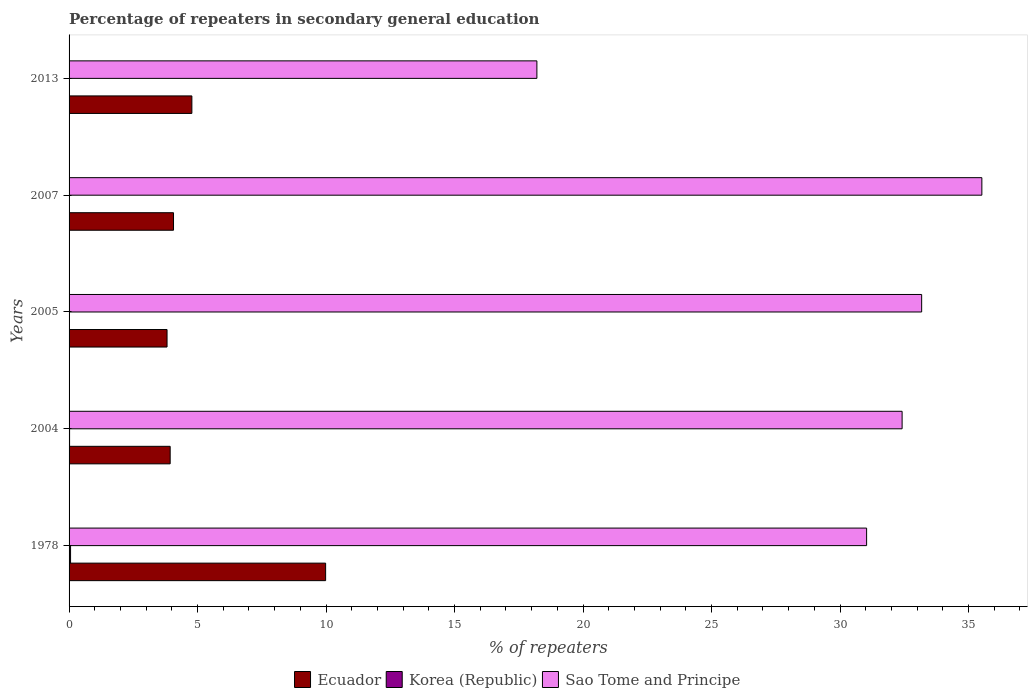Are the number of bars on each tick of the Y-axis equal?
Your answer should be very brief. Yes. How many bars are there on the 2nd tick from the top?
Offer a terse response. 3. How many bars are there on the 3rd tick from the bottom?
Make the answer very short. 3. What is the label of the 5th group of bars from the top?
Your answer should be very brief. 1978. In how many cases, is the number of bars for a given year not equal to the number of legend labels?
Provide a succinct answer. 0. What is the percentage of repeaters in secondary general education in Ecuador in 2013?
Your answer should be very brief. 4.78. Across all years, what is the maximum percentage of repeaters in secondary general education in Sao Tome and Principe?
Offer a terse response. 35.52. Across all years, what is the minimum percentage of repeaters in secondary general education in Sao Tome and Principe?
Ensure brevity in your answer.  18.2. In which year was the percentage of repeaters in secondary general education in Ecuador maximum?
Keep it short and to the point. 1978. In which year was the percentage of repeaters in secondary general education in Sao Tome and Principe minimum?
Offer a very short reply. 2013. What is the total percentage of repeaters in secondary general education in Sao Tome and Principe in the graph?
Provide a short and direct response. 150.34. What is the difference between the percentage of repeaters in secondary general education in Korea (Republic) in 2004 and that in 2013?
Make the answer very short. 0.01. What is the difference between the percentage of repeaters in secondary general education in Ecuador in 1978 and the percentage of repeaters in secondary general education in Korea (Republic) in 2007?
Make the answer very short. 9.98. What is the average percentage of repeaters in secondary general education in Korea (Republic) per year?
Provide a succinct answer. 0.02. In the year 2013, what is the difference between the percentage of repeaters in secondary general education in Korea (Republic) and percentage of repeaters in secondary general education in Sao Tome and Principe?
Provide a short and direct response. -18.2. In how many years, is the percentage of repeaters in secondary general education in Ecuador greater than 15 %?
Offer a terse response. 0. What is the ratio of the percentage of repeaters in secondary general education in Korea (Republic) in 1978 to that in 2013?
Provide a short and direct response. 10.37. Is the percentage of repeaters in secondary general education in Sao Tome and Principe in 1978 less than that in 2007?
Make the answer very short. Yes. What is the difference between the highest and the second highest percentage of repeaters in secondary general education in Ecuador?
Provide a short and direct response. 5.2. What is the difference between the highest and the lowest percentage of repeaters in secondary general education in Ecuador?
Your response must be concise. 6.17. In how many years, is the percentage of repeaters in secondary general education in Sao Tome and Principe greater than the average percentage of repeaters in secondary general education in Sao Tome and Principe taken over all years?
Provide a short and direct response. 4. Is the sum of the percentage of repeaters in secondary general education in Sao Tome and Principe in 2007 and 2013 greater than the maximum percentage of repeaters in secondary general education in Korea (Republic) across all years?
Ensure brevity in your answer.  Yes. What does the 1st bar from the top in 2007 represents?
Make the answer very short. Sao Tome and Principe. Is it the case that in every year, the sum of the percentage of repeaters in secondary general education in Korea (Republic) and percentage of repeaters in secondary general education in Sao Tome and Principe is greater than the percentage of repeaters in secondary general education in Ecuador?
Make the answer very short. Yes. How many years are there in the graph?
Your response must be concise. 5. Are the values on the major ticks of X-axis written in scientific E-notation?
Ensure brevity in your answer.  No. Does the graph contain grids?
Ensure brevity in your answer.  No. Where does the legend appear in the graph?
Provide a short and direct response. Bottom center. How many legend labels are there?
Your answer should be very brief. 3. What is the title of the graph?
Offer a terse response. Percentage of repeaters in secondary general education. What is the label or title of the X-axis?
Provide a succinct answer. % of repeaters. What is the % of repeaters of Ecuador in 1978?
Provide a short and direct response. 9.98. What is the % of repeaters in Korea (Republic) in 1978?
Provide a succinct answer. 0.06. What is the % of repeaters in Sao Tome and Principe in 1978?
Give a very brief answer. 31.03. What is the % of repeaters in Ecuador in 2004?
Ensure brevity in your answer.  3.93. What is the % of repeaters of Korea (Republic) in 2004?
Your answer should be very brief. 0.02. What is the % of repeaters of Sao Tome and Principe in 2004?
Keep it short and to the point. 32.41. What is the % of repeaters in Ecuador in 2005?
Provide a short and direct response. 3.81. What is the % of repeaters of Korea (Republic) in 2005?
Offer a terse response. 0. What is the % of repeaters in Sao Tome and Principe in 2005?
Make the answer very short. 33.18. What is the % of repeaters of Ecuador in 2007?
Provide a succinct answer. 4.06. What is the % of repeaters in Korea (Republic) in 2007?
Keep it short and to the point. 0. What is the % of repeaters of Sao Tome and Principe in 2007?
Keep it short and to the point. 35.52. What is the % of repeaters of Ecuador in 2013?
Provide a short and direct response. 4.78. What is the % of repeaters in Korea (Republic) in 2013?
Offer a very short reply. 0.01. What is the % of repeaters in Sao Tome and Principe in 2013?
Your answer should be very brief. 18.2. Across all years, what is the maximum % of repeaters of Ecuador?
Offer a terse response. 9.98. Across all years, what is the maximum % of repeaters of Korea (Republic)?
Provide a short and direct response. 0.06. Across all years, what is the maximum % of repeaters in Sao Tome and Principe?
Provide a short and direct response. 35.52. Across all years, what is the minimum % of repeaters in Ecuador?
Offer a terse response. 3.81. Across all years, what is the minimum % of repeaters in Korea (Republic)?
Keep it short and to the point. 0. Across all years, what is the minimum % of repeaters of Sao Tome and Principe?
Your answer should be compact. 18.2. What is the total % of repeaters in Ecuador in the graph?
Provide a succinct answer. 26.57. What is the total % of repeaters of Korea (Republic) in the graph?
Offer a very short reply. 0.09. What is the total % of repeaters in Sao Tome and Principe in the graph?
Your response must be concise. 150.34. What is the difference between the % of repeaters in Ecuador in 1978 and that in 2004?
Your answer should be very brief. 6.05. What is the difference between the % of repeaters of Korea (Republic) in 1978 and that in 2004?
Offer a very short reply. 0.04. What is the difference between the % of repeaters in Sao Tome and Principe in 1978 and that in 2004?
Ensure brevity in your answer.  -1.38. What is the difference between the % of repeaters of Ecuador in 1978 and that in 2005?
Your answer should be compact. 6.17. What is the difference between the % of repeaters in Korea (Republic) in 1978 and that in 2005?
Offer a terse response. 0.05. What is the difference between the % of repeaters in Sao Tome and Principe in 1978 and that in 2005?
Make the answer very short. -2.14. What is the difference between the % of repeaters of Ecuador in 1978 and that in 2007?
Your answer should be very brief. 5.92. What is the difference between the % of repeaters in Korea (Republic) in 1978 and that in 2007?
Provide a short and direct response. 0.05. What is the difference between the % of repeaters in Sao Tome and Principe in 1978 and that in 2007?
Offer a terse response. -4.48. What is the difference between the % of repeaters in Ecuador in 1978 and that in 2013?
Ensure brevity in your answer.  5.2. What is the difference between the % of repeaters of Korea (Republic) in 1978 and that in 2013?
Your response must be concise. 0.05. What is the difference between the % of repeaters in Sao Tome and Principe in 1978 and that in 2013?
Give a very brief answer. 12.83. What is the difference between the % of repeaters of Ecuador in 2004 and that in 2005?
Your answer should be compact. 0.12. What is the difference between the % of repeaters of Korea (Republic) in 2004 and that in 2005?
Provide a succinct answer. 0.02. What is the difference between the % of repeaters in Sao Tome and Principe in 2004 and that in 2005?
Offer a very short reply. -0.76. What is the difference between the % of repeaters in Ecuador in 2004 and that in 2007?
Provide a succinct answer. -0.13. What is the difference between the % of repeaters in Korea (Republic) in 2004 and that in 2007?
Your answer should be compact. 0.02. What is the difference between the % of repeaters of Sao Tome and Principe in 2004 and that in 2007?
Your answer should be compact. -3.1. What is the difference between the % of repeaters of Ecuador in 2004 and that in 2013?
Your response must be concise. -0.84. What is the difference between the % of repeaters of Korea (Republic) in 2004 and that in 2013?
Keep it short and to the point. 0.01. What is the difference between the % of repeaters in Sao Tome and Principe in 2004 and that in 2013?
Offer a very short reply. 14.21. What is the difference between the % of repeaters in Ecuador in 2005 and that in 2007?
Your answer should be compact. -0.25. What is the difference between the % of repeaters in Korea (Republic) in 2005 and that in 2007?
Your answer should be compact. 0. What is the difference between the % of repeaters in Sao Tome and Principe in 2005 and that in 2007?
Offer a terse response. -2.34. What is the difference between the % of repeaters of Ecuador in 2005 and that in 2013?
Your answer should be very brief. -0.97. What is the difference between the % of repeaters in Korea (Republic) in 2005 and that in 2013?
Offer a very short reply. -0. What is the difference between the % of repeaters of Sao Tome and Principe in 2005 and that in 2013?
Your answer should be compact. 14.97. What is the difference between the % of repeaters of Ecuador in 2007 and that in 2013?
Ensure brevity in your answer.  -0.71. What is the difference between the % of repeaters of Korea (Republic) in 2007 and that in 2013?
Keep it short and to the point. -0. What is the difference between the % of repeaters of Sao Tome and Principe in 2007 and that in 2013?
Offer a terse response. 17.31. What is the difference between the % of repeaters of Ecuador in 1978 and the % of repeaters of Korea (Republic) in 2004?
Your answer should be compact. 9.96. What is the difference between the % of repeaters of Ecuador in 1978 and the % of repeaters of Sao Tome and Principe in 2004?
Offer a very short reply. -22.43. What is the difference between the % of repeaters in Korea (Republic) in 1978 and the % of repeaters in Sao Tome and Principe in 2004?
Provide a succinct answer. -32.36. What is the difference between the % of repeaters in Ecuador in 1978 and the % of repeaters in Korea (Republic) in 2005?
Your response must be concise. 9.98. What is the difference between the % of repeaters of Ecuador in 1978 and the % of repeaters of Sao Tome and Principe in 2005?
Your answer should be compact. -23.19. What is the difference between the % of repeaters in Korea (Republic) in 1978 and the % of repeaters in Sao Tome and Principe in 2005?
Offer a very short reply. -33.12. What is the difference between the % of repeaters of Ecuador in 1978 and the % of repeaters of Korea (Republic) in 2007?
Your answer should be compact. 9.98. What is the difference between the % of repeaters in Ecuador in 1978 and the % of repeaters in Sao Tome and Principe in 2007?
Provide a short and direct response. -25.53. What is the difference between the % of repeaters in Korea (Republic) in 1978 and the % of repeaters in Sao Tome and Principe in 2007?
Ensure brevity in your answer.  -35.46. What is the difference between the % of repeaters of Ecuador in 1978 and the % of repeaters of Korea (Republic) in 2013?
Make the answer very short. 9.98. What is the difference between the % of repeaters of Ecuador in 1978 and the % of repeaters of Sao Tome and Principe in 2013?
Your response must be concise. -8.22. What is the difference between the % of repeaters in Korea (Republic) in 1978 and the % of repeaters in Sao Tome and Principe in 2013?
Provide a succinct answer. -18.15. What is the difference between the % of repeaters in Ecuador in 2004 and the % of repeaters in Korea (Republic) in 2005?
Your answer should be compact. 3.93. What is the difference between the % of repeaters of Ecuador in 2004 and the % of repeaters of Sao Tome and Principe in 2005?
Provide a short and direct response. -29.24. What is the difference between the % of repeaters in Korea (Republic) in 2004 and the % of repeaters in Sao Tome and Principe in 2005?
Your response must be concise. -33.16. What is the difference between the % of repeaters of Ecuador in 2004 and the % of repeaters of Korea (Republic) in 2007?
Ensure brevity in your answer.  3.93. What is the difference between the % of repeaters in Ecuador in 2004 and the % of repeaters in Sao Tome and Principe in 2007?
Your response must be concise. -31.58. What is the difference between the % of repeaters in Korea (Republic) in 2004 and the % of repeaters in Sao Tome and Principe in 2007?
Provide a short and direct response. -35.5. What is the difference between the % of repeaters in Ecuador in 2004 and the % of repeaters in Korea (Republic) in 2013?
Keep it short and to the point. 3.93. What is the difference between the % of repeaters of Ecuador in 2004 and the % of repeaters of Sao Tome and Principe in 2013?
Provide a short and direct response. -14.27. What is the difference between the % of repeaters of Korea (Republic) in 2004 and the % of repeaters of Sao Tome and Principe in 2013?
Offer a very short reply. -18.18. What is the difference between the % of repeaters in Ecuador in 2005 and the % of repeaters in Korea (Republic) in 2007?
Provide a succinct answer. 3.81. What is the difference between the % of repeaters of Ecuador in 2005 and the % of repeaters of Sao Tome and Principe in 2007?
Give a very brief answer. -31.71. What is the difference between the % of repeaters of Korea (Republic) in 2005 and the % of repeaters of Sao Tome and Principe in 2007?
Provide a short and direct response. -35.51. What is the difference between the % of repeaters in Ecuador in 2005 and the % of repeaters in Korea (Republic) in 2013?
Keep it short and to the point. 3.81. What is the difference between the % of repeaters of Ecuador in 2005 and the % of repeaters of Sao Tome and Principe in 2013?
Provide a succinct answer. -14.39. What is the difference between the % of repeaters of Korea (Republic) in 2005 and the % of repeaters of Sao Tome and Principe in 2013?
Keep it short and to the point. -18.2. What is the difference between the % of repeaters of Ecuador in 2007 and the % of repeaters of Korea (Republic) in 2013?
Your answer should be compact. 4.06. What is the difference between the % of repeaters in Ecuador in 2007 and the % of repeaters in Sao Tome and Principe in 2013?
Keep it short and to the point. -14.14. What is the difference between the % of repeaters in Korea (Republic) in 2007 and the % of repeaters in Sao Tome and Principe in 2013?
Make the answer very short. -18.2. What is the average % of repeaters of Ecuador per year?
Your answer should be very brief. 5.31. What is the average % of repeaters in Korea (Republic) per year?
Ensure brevity in your answer.  0.02. What is the average % of repeaters in Sao Tome and Principe per year?
Give a very brief answer. 30.07. In the year 1978, what is the difference between the % of repeaters in Ecuador and % of repeaters in Korea (Republic)?
Make the answer very short. 9.92. In the year 1978, what is the difference between the % of repeaters in Ecuador and % of repeaters in Sao Tome and Principe?
Your response must be concise. -21.05. In the year 1978, what is the difference between the % of repeaters in Korea (Republic) and % of repeaters in Sao Tome and Principe?
Make the answer very short. -30.98. In the year 2004, what is the difference between the % of repeaters of Ecuador and % of repeaters of Korea (Republic)?
Offer a very short reply. 3.91. In the year 2004, what is the difference between the % of repeaters of Ecuador and % of repeaters of Sao Tome and Principe?
Provide a succinct answer. -28.48. In the year 2004, what is the difference between the % of repeaters in Korea (Republic) and % of repeaters in Sao Tome and Principe?
Your response must be concise. -32.4. In the year 2005, what is the difference between the % of repeaters in Ecuador and % of repeaters in Korea (Republic)?
Offer a very short reply. 3.81. In the year 2005, what is the difference between the % of repeaters of Ecuador and % of repeaters of Sao Tome and Principe?
Offer a terse response. -29.36. In the year 2005, what is the difference between the % of repeaters of Korea (Republic) and % of repeaters of Sao Tome and Principe?
Your response must be concise. -33.17. In the year 2007, what is the difference between the % of repeaters in Ecuador and % of repeaters in Korea (Republic)?
Provide a short and direct response. 4.06. In the year 2007, what is the difference between the % of repeaters in Ecuador and % of repeaters in Sao Tome and Principe?
Offer a terse response. -31.45. In the year 2007, what is the difference between the % of repeaters of Korea (Republic) and % of repeaters of Sao Tome and Principe?
Your response must be concise. -35.51. In the year 2013, what is the difference between the % of repeaters in Ecuador and % of repeaters in Korea (Republic)?
Make the answer very short. 4.77. In the year 2013, what is the difference between the % of repeaters in Ecuador and % of repeaters in Sao Tome and Principe?
Offer a very short reply. -13.43. In the year 2013, what is the difference between the % of repeaters in Korea (Republic) and % of repeaters in Sao Tome and Principe?
Make the answer very short. -18.2. What is the ratio of the % of repeaters in Ecuador in 1978 to that in 2004?
Make the answer very short. 2.54. What is the ratio of the % of repeaters in Korea (Republic) in 1978 to that in 2004?
Offer a very short reply. 2.94. What is the ratio of the % of repeaters of Sao Tome and Principe in 1978 to that in 2004?
Provide a short and direct response. 0.96. What is the ratio of the % of repeaters in Ecuador in 1978 to that in 2005?
Offer a terse response. 2.62. What is the ratio of the % of repeaters of Korea (Republic) in 1978 to that in 2005?
Offer a very short reply. 12.92. What is the ratio of the % of repeaters of Sao Tome and Principe in 1978 to that in 2005?
Provide a succinct answer. 0.94. What is the ratio of the % of repeaters of Ecuador in 1978 to that in 2007?
Your answer should be compact. 2.46. What is the ratio of the % of repeaters of Korea (Republic) in 1978 to that in 2007?
Give a very brief answer. 13.49. What is the ratio of the % of repeaters of Sao Tome and Principe in 1978 to that in 2007?
Your response must be concise. 0.87. What is the ratio of the % of repeaters in Ecuador in 1978 to that in 2013?
Offer a terse response. 2.09. What is the ratio of the % of repeaters in Korea (Republic) in 1978 to that in 2013?
Offer a very short reply. 10.37. What is the ratio of the % of repeaters of Sao Tome and Principe in 1978 to that in 2013?
Provide a succinct answer. 1.7. What is the ratio of the % of repeaters in Ecuador in 2004 to that in 2005?
Give a very brief answer. 1.03. What is the ratio of the % of repeaters in Korea (Republic) in 2004 to that in 2005?
Your response must be concise. 4.39. What is the ratio of the % of repeaters in Sao Tome and Principe in 2004 to that in 2005?
Ensure brevity in your answer.  0.98. What is the ratio of the % of repeaters in Korea (Republic) in 2004 to that in 2007?
Make the answer very short. 4.59. What is the ratio of the % of repeaters of Sao Tome and Principe in 2004 to that in 2007?
Make the answer very short. 0.91. What is the ratio of the % of repeaters in Ecuador in 2004 to that in 2013?
Offer a terse response. 0.82. What is the ratio of the % of repeaters of Korea (Republic) in 2004 to that in 2013?
Make the answer very short. 3.53. What is the ratio of the % of repeaters in Sao Tome and Principe in 2004 to that in 2013?
Your answer should be very brief. 1.78. What is the ratio of the % of repeaters of Ecuador in 2005 to that in 2007?
Make the answer very short. 0.94. What is the ratio of the % of repeaters in Korea (Republic) in 2005 to that in 2007?
Give a very brief answer. 1.04. What is the ratio of the % of repeaters in Sao Tome and Principe in 2005 to that in 2007?
Provide a succinct answer. 0.93. What is the ratio of the % of repeaters of Ecuador in 2005 to that in 2013?
Provide a succinct answer. 0.8. What is the ratio of the % of repeaters in Korea (Republic) in 2005 to that in 2013?
Give a very brief answer. 0.8. What is the ratio of the % of repeaters of Sao Tome and Principe in 2005 to that in 2013?
Your response must be concise. 1.82. What is the ratio of the % of repeaters in Ecuador in 2007 to that in 2013?
Provide a short and direct response. 0.85. What is the ratio of the % of repeaters in Korea (Republic) in 2007 to that in 2013?
Offer a terse response. 0.77. What is the ratio of the % of repeaters of Sao Tome and Principe in 2007 to that in 2013?
Ensure brevity in your answer.  1.95. What is the difference between the highest and the second highest % of repeaters of Ecuador?
Offer a very short reply. 5.2. What is the difference between the highest and the second highest % of repeaters in Korea (Republic)?
Make the answer very short. 0.04. What is the difference between the highest and the second highest % of repeaters of Sao Tome and Principe?
Your answer should be very brief. 2.34. What is the difference between the highest and the lowest % of repeaters of Ecuador?
Provide a short and direct response. 6.17. What is the difference between the highest and the lowest % of repeaters of Korea (Republic)?
Provide a short and direct response. 0.05. What is the difference between the highest and the lowest % of repeaters of Sao Tome and Principe?
Your answer should be compact. 17.31. 